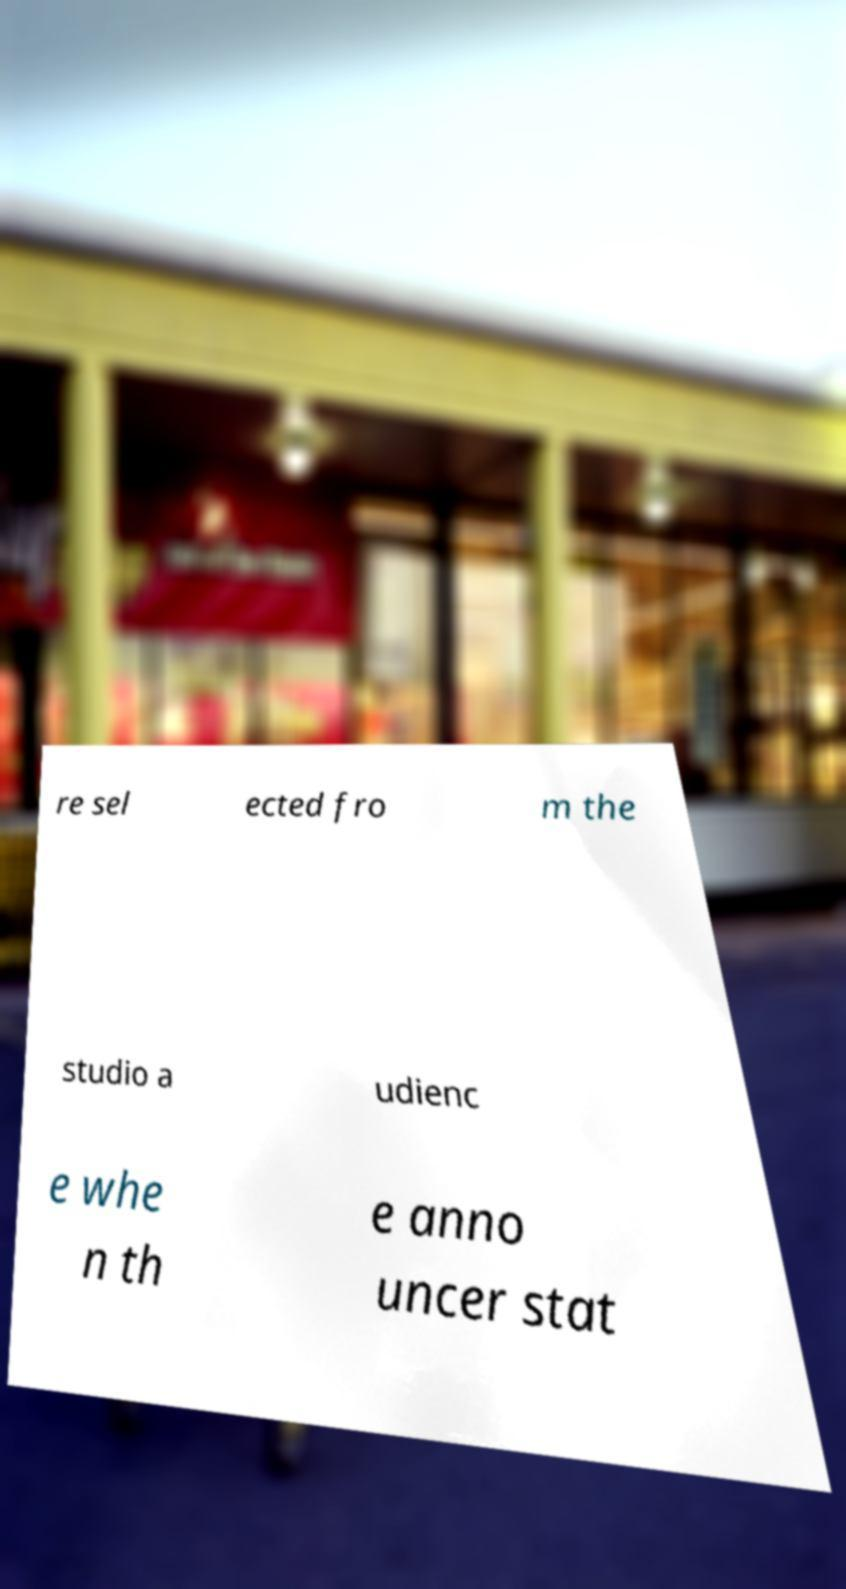Can you accurately transcribe the text from the provided image for me? re sel ected fro m the studio a udienc e whe n th e anno uncer stat 